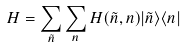<formula> <loc_0><loc_0><loc_500><loc_500>H = \sum _ { \tilde { n } } \sum _ { n } H ( \tilde { n } , { n } ) | \tilde { n } \rangle \langle { n } |</formula> 